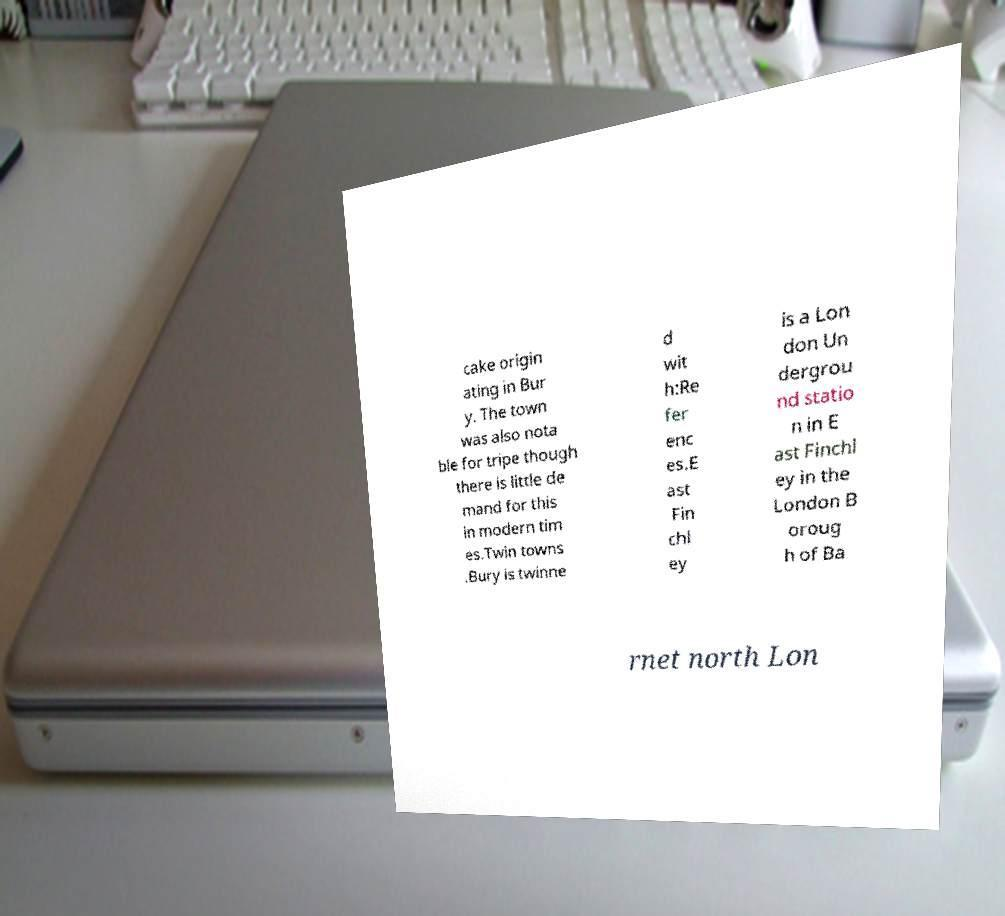Could you extract and type out the text from this image? cake origin ating in Bur y. The town was also nota ble for tripe though there is little de mand for this in modern tim es.Twin towns .Bury is twinne d wit h:Re fer enc es.E ast Fin chl ey is a Lon don Un dergrou nd statio n in E ast Finchl ey in the London B oroug h of Ba rnet north Lon 